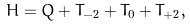Convert formula to latex. <formula><loc_0><loc_0><loc_500><loc_500>H = Q + T _ { - 2 } + T _ { 0 } + T _ { + 2 } ,</formula> 